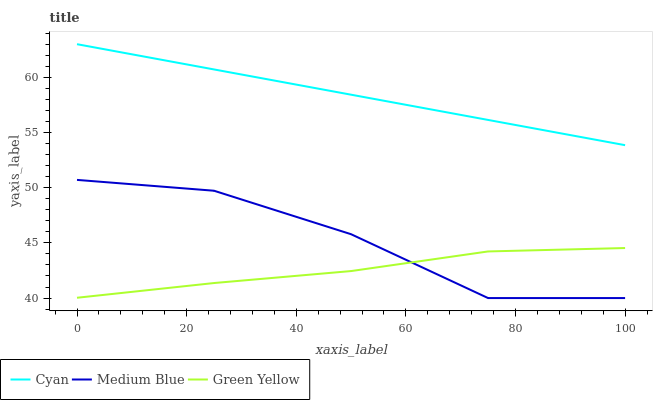Does Green Yellow have the minimum area under the curve?
Answer yes or no. Yes. Does Cyan have the maximum area under the curve?
Answer yes or no. Yes. Does Medium Blue have the minimum area under the curve?
Answer yes or no. No. Does Medium Blue have the maximum area under the curve?
Answer yes or no. No. Is Cyan the smoothest?
Answer yes or no. Yes. Is Medium Blue the roughest?
Answer yes or no. Yes. Is Green Yellow the smoothest?
Answer yes or no. No. Is Green Yellow the roughest?
Answer yes or no. No. Does Green Yellow have the lowest value?
Answer yes or no. No. Does Cyan have the highest value?
Answer yes or no. Yes. Does Medium Blue have the highest value?
Answer yes or no. No. Is Medium Blue less than Cyan?
Answer yes or no. Yes. Is Cyan greater than Medium Blue?
Answer yes or no. Yes. Does Green Yellow intersect Medium Blue?
Answer yes or no. Yes. Is Green Yellow less than Medium Blue?
Answer yes or no. No. Is Green Yellow greater than Medium Blue?
Answer yes or no. No. Does Medium Blue intersect Cyan?
Answer yes or no. No. 